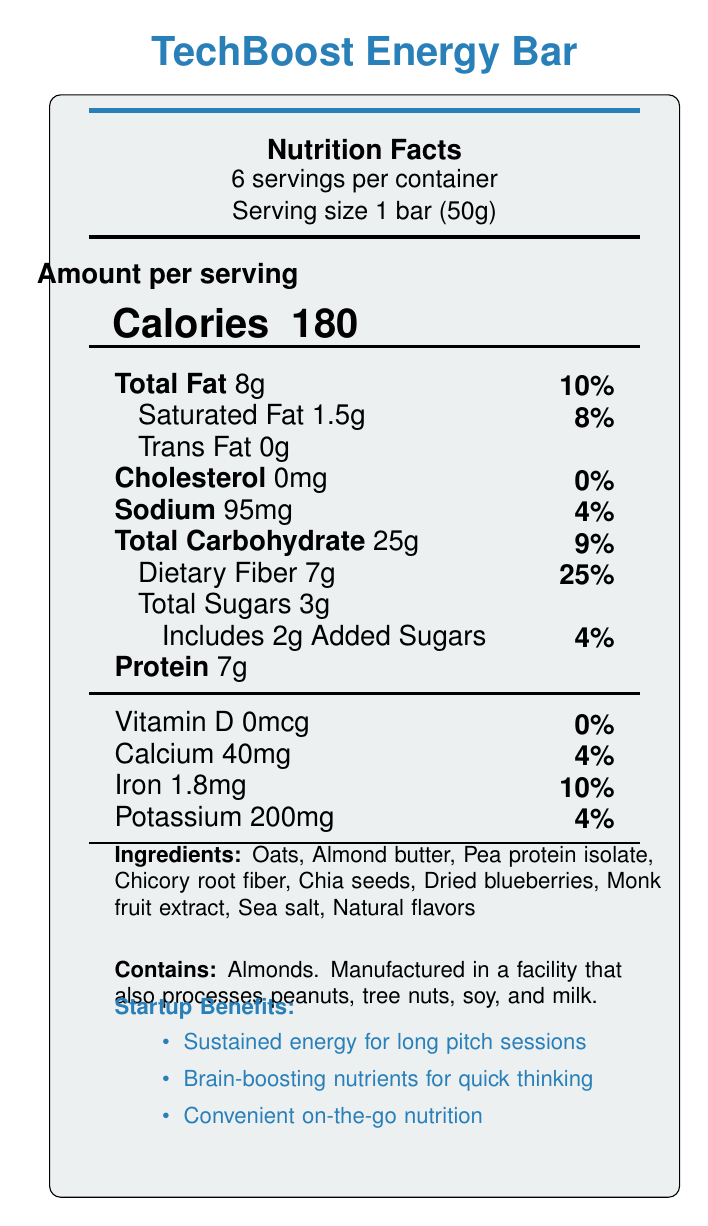what is the serving size? The serving size is explicitly mentioned as "Serving size 1 bar (50g)".
Answer: 1 bar (50g) how many calories are there per serving? The document states, "Calories 180" under the "Amount per serving" section.
Answer: 180 what is the total fat content per serving? The total fat content is listed as "Total Fat 8g".
Answer: 8g how much dietary fiber is in each serving? The dietary fiber amount is given as "Dietary Fiber 7g".
Answer: 7g what are the main ingredients in the TechBoost Energy Bar? The ingredients are listed under "Ingredients".
Answer: Oats, Almond butter, Pea protein isolate, Chicory root fiber, Chia seeds, Dried blueberries, Monk fruit extract, Sea salt, Natural flavors what percentage of the daily value of saturated fat does one serving contain? The document indicates "Saturated Fat 1.5g" and its daily value as "8%".
Answer: 8% how much sugar is added to the TechBoost Energy Bar? A. 1g B. 2g C. 3g D. 4g The document mentions "Includes 2g Added Sugars" under the sugars section.
Answer: B. 2g which nutrient has the highest daily value percentage per serving? A. Calcium B. Iron C. Sodium D. Dietary Fiber The nutrient with the highest daily value percentage per serving is "Dietary Fiber" with "25%".
Answer: D. Dietary Fiber does the TechBoost Energy Bar contain any cholesterol? The document specifies "Cholesterol 0mg" with a daily value of "0%".
Answer: No is this snack bar suitable for someone on a gluten-free diet? The product claims include "Gluten-free".
Answer: Yes summarize the main benefits of the TechBoost Energy Bar for startup founders. The document highlights the benefits under "Startup Benefits" which include sustained energy for long pitch sessions, brain-boosting nutrients, and convenient on-the-go nutrition.
Answer: The TechBoost Energy Bar provides sustained energy release for long pitch sessions, brain-boosting nutrients for quick thinking, and convenient on-the-go nutrition for busy entrepreneurs. how many bars are there in one container? The document states "6 servings per container" and the serving size is 1 bar.
Answer: 6 bars what flavor is the TechBoost Energy Bar? The specific flavor of the TechBoost Energy Bar is not mentioned in the document.
Answer: Not enough information is there any information about the manufacturing facility's allergen processes? The document includes an allergen warning: "Manufactured in a facility that also processes peanuts, tree nuts, soy, and milk."
Answer: Yes what percentage of the daily value of iron does one serving contain? The document lists "Iron 1.8mg" with a daily value of "10%".
Answer: 10% 